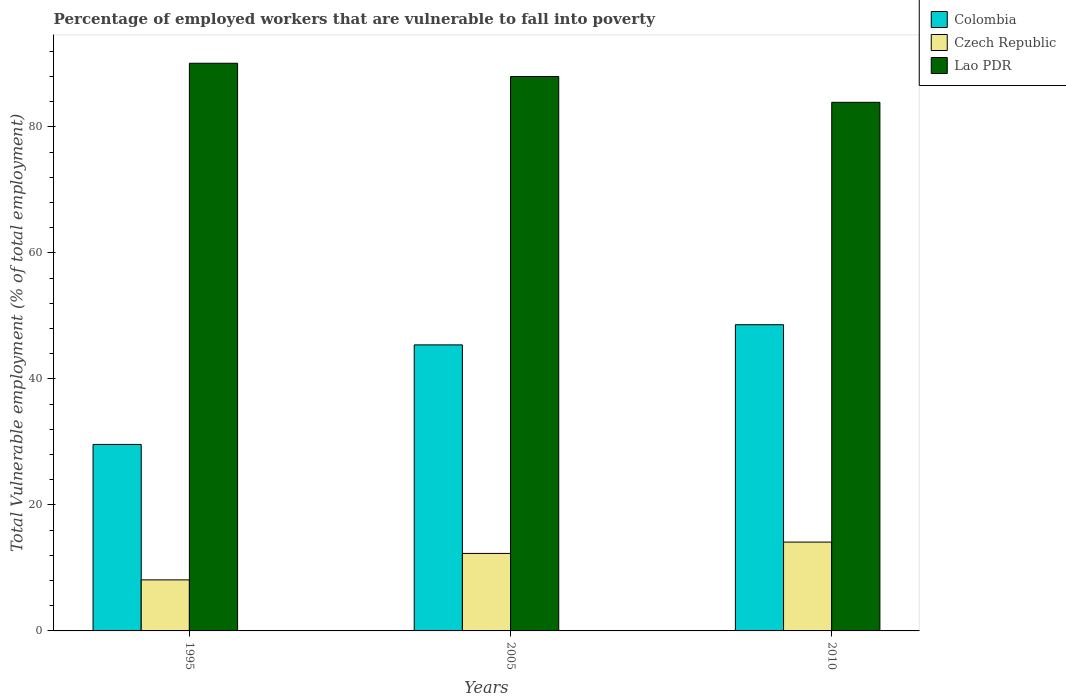How many different coloured bars are there?
Give a very brief answer. 3. How many groups of bars are there?
Make the answer very short. 3. How many bars are there on the 1st tick from the right?
Ensure brevity in your answer.  3. What is the label of the 2nd group of bars from the left?
Provide a succinct answer. 2005. In how many cases, is the number of bars for a given year not equal to the number of legend labels?
Provide a succinct answer. 0. What is the percentage of employed workers who are vulnerable to fall into poverty in Colombia in 2010?
Make the answer very short. 48.6. Across all years, what is the maximum percentage of employed workers who are vulnerable to fall into poverty in Lao PDR?
Make the answer very short. 90.1. Across all years, what is the minimum percentage of employed workers who are vulnerable to fall into poverty in Czech Republic?
Your answer should be compact. 8.1. In which year was the percentage of employed workers who are vulnerable to fall into poverty in Lao PDR maximum?
Offer a terse response. 1995. What is the total percentage of employed workers who are vulnerable to fall into poverty in Czech Republic in the graph?
Offer a very short reply. 34.5. What is the difference between the percentage of employed workers who are vulnerable to fall into poverty in Colombia in 1995 and that in 2010?
Your answer should be very brief. -19. What is the difference between the percentage of employed workers who are vulnerable to fall into poverty in Colombia in 2010 and the percentage of employed workers who are vulnerable to fall into poverty in Lao PDR in 1995?
Offer a terse response. -41.5. What is the average percentage of employed workers who are vulnerable to fall into poverty in Colombia per year?
Provide a short and direct response. 41.2. In the year 2010, what is the difference between the percentage of employed workers who are vulnerable to fall into poverty in Colombia and percentage of employed workers who are vulnerable to fall into poverty in Czech Republic?
Offer a very short reply. 34.5. What is the ratio of the percentage of employed workers who are vulnerable to fall into poverty in Lao PDR in 1995 to that in 2010?
Provide a short and direct response. 1.07. Is the difference between the percentage of employed workers who are vulnerable to fall into poverty in Colombia in 1995 and 2010 greater than the difference between the percentage of employed workers who are vulnerable to fall into poverty in Czech Republic in 1995 and 2010?
Provide a succinct answer. No. What is the difference between the highest and the second highest percentage of employed workers who are vulnerable to fall into poverty in Czech Republic?
Offer a very short reply. 1.8. What is the difference between the highest and the lowest percentage of employed workers who are vulnerable to fall into poverty in Colombia?
Your answer should be compact. 19. What does the 2nd bar from the left in 2010 represents?
Give a very brief answer. Czech Republic. What does the 2nd bar from the right in 2010 represents?
Your answer should be very brief. Czech Republic. How many bars are there?
Give a very brief answer. 9. Are all the bars in the graph horizontal?
Offer a very short reply. No. How many years are there in the graph?
Provide a short and direct response. 3. What is the difference between two consecutive major ticks on the Y-axis?
Keep it short and to the point. 20. Are the values on the major ticks of Y-axis written in scientific E-notation?
Provide a short and direct response. No. Where does the legend appear in the graph?
Offer a terse response. Top right. What is the title of the graph?
Give a very brief answer. Percentage of employed workers that are vulnerable to fall into poverty. Does "Vietnam" appear as one of the legend labels in the graph?
Your answer should be very brief. No. What is the label or title of the X-axis?
Ensure brevity in your answer.  Years. What is the label or title of the Y-axis?
Provide a short and direct response. Total Vulnerable employment (% of total employment). What is the Total Vulnerable employment (% of total employment) of Colombia in 1995?
Offer a terse response. 29.6. What is the Total Vulnerable employment (% of total employment) in Czech Republic in 1995?
Ensure brevity in your answer.  8.1. What is the Total Vulnerable employment (% of total employment) of Lao PDR in 1995?
Offer a terse response. 90.1. What is the Total Vulnerable employment (% of total employment) in Colombia in 2005?
Provide a succinct answer. 45.4. What is the Total Vulnerable employment (% of total employment) in Czech Republic in 2005?
Your response must be concise. 12.3. What is the Total Vulnerable employment (% of total employment) in Colombia in 2010?
Make the answer very short. 48.6. What is the Total Vulnerable employment (% of total employment) of Czech Republic in 2010?
Your response must be concise. 14.1. What is the Total Vulnerable employment (% of total employment) of Lao PDR in 2010?
Your response must be concise. 83.9. Across all years, what is the maximum Total Vulnerable employment (% of total employment) of Colombia?
Your answer should be compact. 48.6. Across all years, what is the maximum Total Vulnerable employment (% of total employment) of Czech Republic?
Your answer should be compact. 14.1. Across all years, what is the maximum Total Vulnerable employment (% of total employment) of Lao PDR?
Ensure brevity in your answer.  90.1. Across all years, what is the minimum Total Vulnerable employment (% of total employment) of Colombia?
Keep it short and to the point. 29.6. Across all years, what is the minimum Total Vulnerable employment (% of total employment) in Czech Republic?
Provide a short and direct response. 8.1. Across all years, what is the minimum Total Vulnerable employment (% of total employment) in Lao PDR?
Offer a very short reply. 83.9. What is the total Total Vulnerable employment (% of total employment) of Colombia in the graph?
Offer a very short reply. 123.6. What is the total Total Vulnerable employment (% of total employment) of Czech Republic in the graph?
Your response must be concise. 34.5. What is the total Total Vulnerable employment (% of total employment) of Lao PDR in the graph?
Ensure brevity in your answer.  262. What is the difference between the Total Vulnerable employment (% of total employment) in Colombia in 1995 and that in 2005?
Offer a very short reply. -15.8. What is the difference between the Total Vulnerable employment (% of total employment) of Colombia in 1995 and that in 2010?
Keep it short and to the point. -19. What is the difference between the Total Vulnerable employment (% of total employment) in Czech Republic in 1995 and that in 2010?
Your response must be concise. -6. What is the difference between the Total Vulnerable employment (% of total employment) in Colombia in 1995 and the Total Vulnerable employment (% of total employment) in Czech Republic in 2005?
Keep it short and to the point. 17.3. What is the difference between the Total Vulnerable employment (% of total employment) in Colombia in 1995 and the Total Vulnerable employment (% of total employment) in Lao PDR in 2005?
Provide a succinct answer. -58.4. What is the difference between the Total Vulnerable employment (% of total employment) of Czech Republic in 1995 and the Total Vulnerable employment (% of total employment) of Lao PDR in 2005?
Your answer should be compact. -79.9. What is the difference between the Total Vulnerable employment (% of total employment) in Colombia in 1995 and the Total Vulnerable employment (% of total employment) in Lao PDR in 2010?
Provide a succinct answer. -54.3. What is the difference between the Total Vulnerable employment (% of total employment) in Czech Republic in 1995 and the Total Vulnerable employment (% of total employment) in Lao PDR in 2010?
Your answer should be very brief. -75.8. What is the difference between the Total Vulnerable employment (% of total employment) of Colombia in 2005 and the Total Vulnerable employment (% of total employment) of Czech Republic in 2010?
Provide a succinct answer. 31.3. What is the difference between the Total Vulnerable employment (% of total employment) of Colombia in 2005 and the Total Vulnerable employment (% of total employment) of Lao PDR in 2010?
Make the answer very short. -38.5. What is the difference between the Total Vulnerable employment (% of total employment) of Czech Republic in 2005 and the Total Vulnerable employment (% of total employment) of Lao PDR in 2010?
Offer a terse response. -71.6. What is the average Total Vulnerable employment (% of total employment) in Colombia per year?
Your answer should be very brief. 41.2. What is the average Total Vulnerable employment (% of total employment) in Czech Republic per year?
Provide a short and direct response. 11.5. What is the average Total Vulnerable employment (% of total employment) of Lao PDR per year?
Give a very brief answer. 87.33. In the year 1995, what is the difference between the Total Vulnerable employment (% of total employment) in Colombia and Total Vulnerable employment (% of total employment) in Lao PDR?
Your answer should be very brief. -60.5. In the year 1995, what is the difference between the Total Vulnerable employment (% of total employment) in Czech Republic and Total Vulnerable employment (% of total employment) in Lao PDR?
Offer a terse response. -82. In the year 2005, what is the difference between the Total Vulnerable employment (% of total employment) in Colombia and Total Vulnerable employment (% of total employment) in Czech Republic?
Ensure brevity in your answer.  33.1. In the year 2005, what is the difference between the Total Vulnerable employment (% of total employment) in Colombia and Total Vulnerable employment (% of total employment) in Lao PDR?
Keep it short and to the point. -42.6. In the year 2005, what is the difference between the Total Vulnerable employment (% of total employment) of Czech Republic and Total Vulnerable employment (% of total employment) of Lao PDR?
Provide a succinct answer. -75.7. In the year 2010, what is the difference between the Total Vulnerable employment (% of total employment) of Colombia and Total Vulnerable employment (% of total employment) of Czech Republic?
Provide a short and direct response. 34.5. In the year 2010, what is the difference between the Total Vulnerable employment (% of total employment) of Colombia and Total Vulnerable employment (% of total employment) of Lao PDR?
Offer a very short reply. -35.3. In the year 2010, what is the difference between the Total Vulnerable employment (% of total employment) of Czech Republic and Total Vulnerable employment (% of total employment) of Lao PDR?
Your answer should be compact. -69.8. What is the ratio of the Total Vulnerable employment (% of total employment) in Colombia in 1995 to that in 2005?
Give a very brief answer. 0.65. What is the ratio of the Total Vulnerable employment (% of total employment) of Czech Republic in 1995 to that in 2005?
Keep it short and to the point. 0.66. What is the ratio of the Total Vulnerable employment (% of total employment) in Lao PDR in 1995 to that in 2005?
Provide a succinct answer. 1.02. What is the ratio of the Total Vulnerable employment (% of total employment) in Colombia in 1995 to that in 2010?
Make the answer very short. 0.61. What is the ratio of the Total Vulnerable employment (% of total employment) of Czech Republic in 1995 to that in 2010?
Provide a short and direct response. 0.57. What is the ratio of the Total Vulnerable employment (% of total employment) in Lao PDR in 1995 to that in 2010?
Keep it short and to the point. 1.07. What is the ratio of the Total Vulnerable employment (% of total employment) in Colombia in 2005 to that in 2010?
Make the answer very short. 0.93. What is the ratio of the Total Vulnerable employment (% of total employment) of Czech Republic in 2005 to that in 2010?
Your answer should be very brief. 0.87. What is the ratio of the Total Vulnerable employment (% of total employment) in Lao PDR in 2005 to that in 2010?
Give a very brief answer. 1.05. What is the difference between the highest and the second highest Total Vulnerable employment (% of total employment) of Colombia?
Offer a terse response. 3.2. What is the difference between the highest and the lowest Total Vulnerable employment (% of total employment) in Colombia?
Your response must be concise. 19. 